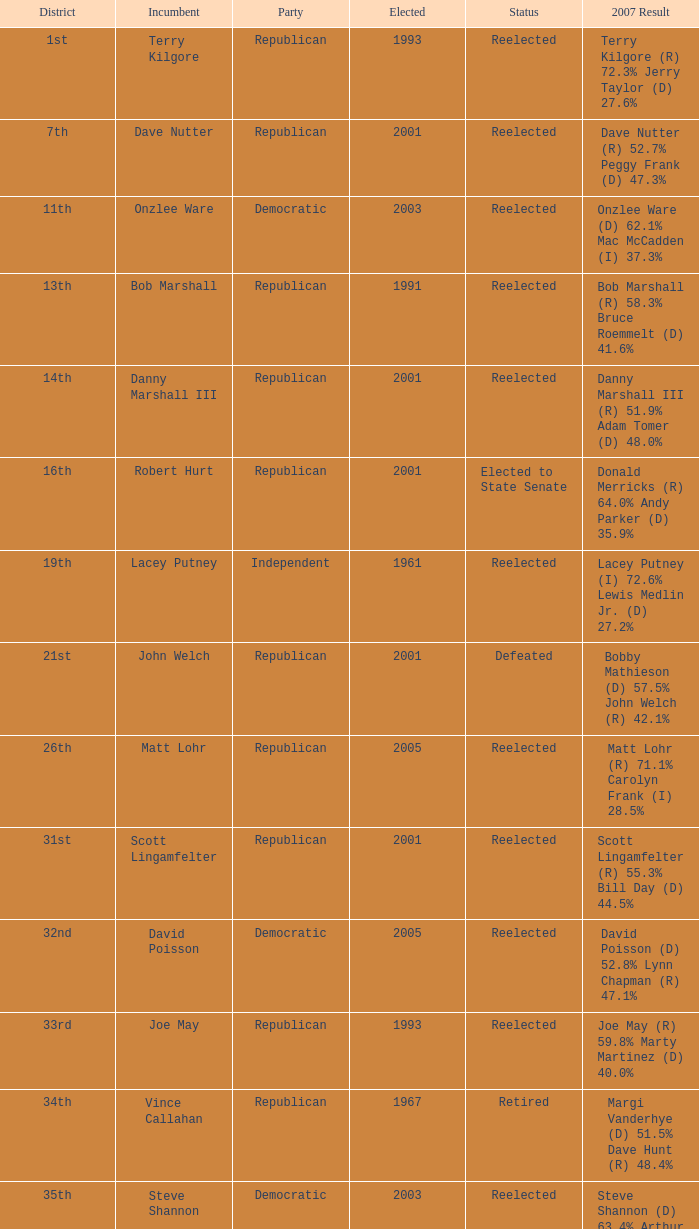Help me parse the entirety of this table. {'header': ['District', 'Incumbent', 'Party', 'Elected', 'Status', '2007 Result'], 'rows': [['1st', 'Terry Kilgore', 'Republican', '1993', 'Reelected', 'Terry Kilgore (R) 72.3% Jerry Taylor (D) 27.6%'], ['7th', 'Dave Nutter', 'Republican', '2001', 'Reelected', 'Dave Nutter (R) 52.7% Peggy Frank (D) 47.3%'], ['11th', 'Onzlee Ware', 'Democratic', '2003', 'Reelected', 'Onzlee Ware (D) 62.1% Mac McCadden (I) 37.3%'], ['13th', 'Bob Marshall', 'Republican', '1991', 'Reelected', 'Bob Marshall (R) 58.3% Bruce Roemmelt (D) 41.6%'], ['14th', 'Danny Marshall III', 'Republican', '2001', 'Reelected', 'Danny Marshall III (R) 51.9% Adam Tomer (D) 48.0%'], ['16th', 'Robert Hurt', 'Republican', '2001', 'Elected to State Senate', 'Donald Merricks (R) 64.0% Andy Parker (D) 35.9%'], ['19th', 'Lacey Putney', 'Independent', '1961', 'Reelected', 'Lacey Putney (I) 72.6% Lewis Medlin Jr. (D) 27.2%'], ['21st', 'John Welch', 'Republican', '2001', 'Defeated', 'Bobby Mathieson (D) 57.5% John Welch (R) 42.1%'], ['26th', 'Matt Lohr', 'Republican', '2005', 'Reelected', 'Matt Lohr (R) 71.1% Carolyn Frank (I) 28.5%'], ['31st', 'Scott Lingamfelter', 'Republican', '2001', 'Reelected', 'Scott Lingamfelter (R) 55.3% Bill Day (D) 44.5%'], ['32nd', 'David Poisson', 'Democratic', '2005', 'Reelected', 'David Poisson (D) 52.8% Lynn Chapman (R) 47.1%'], ['33rd', 'Joe May', 'Republican', '1993', 'Reelected', 'Joe May (R) 59.8% Marty Martinez (D) 40.0%'], ['34th', 'Vince Callahan', 'Republican', '1967', 'Retired', 'Margi Vanderhye (D) 51.5% Dave Hunt (R) 48.4%'], ['35th', 'Steve Shannon', 'Democratic', '2003', 'Reelected', 'Steve Shannon (D) 63.4% Arthur Purves (R) 36.6%'], ['39th', 'Vivian Watts', 'Democratic', '1995', 'Reelected', 'Vivian Watts (D) 78.3% Laura C. Clifton (IG) 21.2%'], ['40th', 'Tim Hugo', 'Republican', '2003', 'Reelected', 'Tim Hugo (R) 57.1% Rex Simmons (D) 42.8%'], ['45th', 'David Englin', 'Democratic', '2005', 'Reelected', 'David Englin (D) 64.2% Mark Allen (R) 35.7%'], ['51st', 'Michele McQuigg', 'Republican', '1997', 'Elected to Clerk of Court', 'Paul Nichols (D) 51.8% Faisal Gill (R) 47.7%'], ['54th', 'Bobby Orrock', 'Republican', '1989', 'Reelected', 'Bobby Orrock (R) 73.7% Kimbra Kincheloe (I) 26.2%'], ['56th', 'Bill Janis', 'Republican', '2001', 'Reelected', 'Bill Janis (R) 65.9% Will Shaw (D) 34.0%'], ['59th', 'Watkins Abbitt', 'Independent', '1985', 'Reelected', 'Watkins Abbitt (I) 60.2% Connie Brennan (D) 39.7%'], ['67th', 'Chuck Caputo', 'Democratic', '2005', 'Reelected', 'Chuck Caputo (D) 52.7% Marc Cadin (R) 47.3%'], ['69th', 'Frank Hall', 'Democratic', '1975', 'Reelected', 'Frank Hall (D) 82.8% Ray Gargiulo (R) 17.0%'], ['72nd', 'Jack Reid', 'Republican', '1989', 'Retired', 'Jimmie Massie (R) 67.2% Tom Herbert (D) 32.7%'], ['78th', 'John Cosgrove', 'Republican', '2001', 'Reelected', 'John Cosgrove (R) 61.7% Mick Meyer (D) 38.2%'], ['82nd', 'Bob Purkey', 'Republican', '1985', 'Reelected', 'Bob Purkey (R) 60.6% Bob MacIver (D) 39.2%'], ['83rd', 'Leo Wardrup', 'Republican', '1991', 'Retired', 'Joe Bouchard (D) 50.6% Chris Stolle (R) 49.2%'], ['86th', 'Tom Rust', 'Republican', '2001', 'Reelected', 'Tom Rust (R) 52.8% Jay Donahue (D) 47.1%'], ['87th', 'Paula Miller', 'Democratic', '2005', 'Reelected', 'Paula Miller (D) 54.0% Hank Giffin (R) 45.8%'], ['88th', 'Mark Cole', 'Republican', '2001', 'Reelected', 'Mark Cole (R) 62.2% Carlos Del Toro (D) 37.6%']]} How many election results are there from the 19th district? 1.0. 